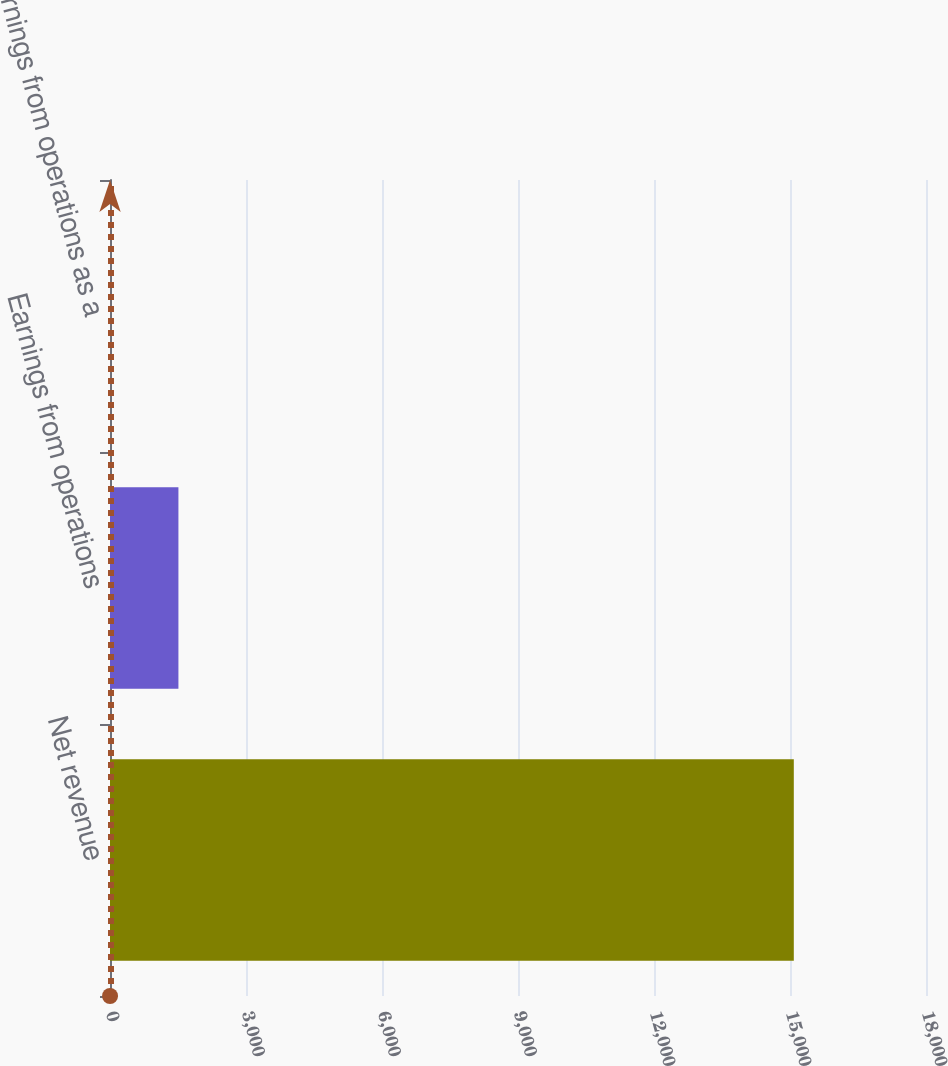<chart> <loc_0><loc_0><loc_500><loc_500><bar_chart><fcel>Net revenue<fcel>Earnings from operations<fcel>Earnings from operations as a<nl><fcel>15084<fcel>1509.3<fcel>1<nl></chart> 